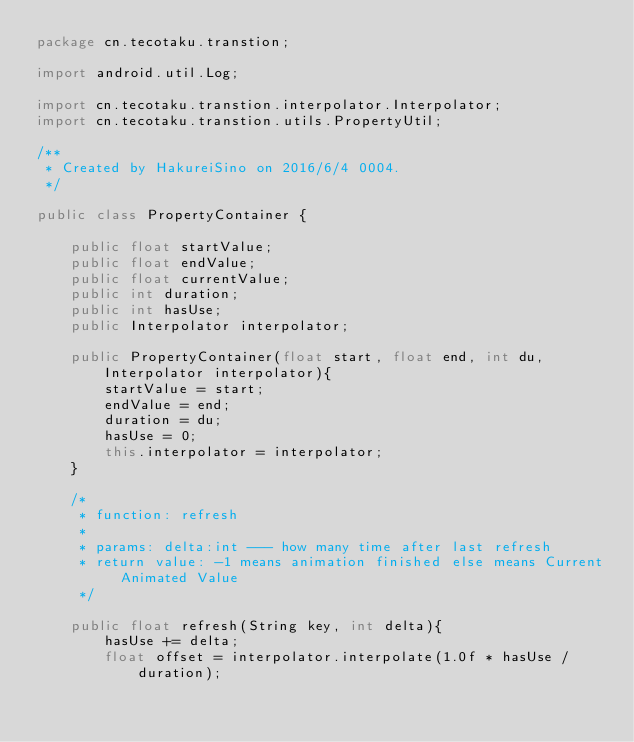<code> <loc_0><loc_0><loc_500><loc_500><_Java_>package cn.tecotaku.transtion;

import android.util.Log;

import cn.tecotaku.transtion.interpolator.Interpolator;
import cn.tecotaku.transtion.utils.PropertyUtil;

/**
 * Created by HakureiSino on 2016/6/4 0004.
 */

public class PropertyContainer {

    public float startValue;
    public float endValue;
    public float currentValue;
    public int duration;
    public int hasUse;
    public Interpolator interpolator;

    public PropertyContainer(float start, float end, int du, Interpolator interpolator){
        startValue = start;
        endValue = end;
        duration = du;
        hasUse = 0;
        this.interpolator = interpolator;
    }

    /*
     * function: refresh
     *
     * params: delta:int --- how many time after last refresh
     * return value: -1 means animation finished else means Current Animated Value
     */

    public float refresh(String key, int delta){
        hasUse += delta;
        float offset = interpolator.interpolate(1.0f * hasUse / duration);</code> 